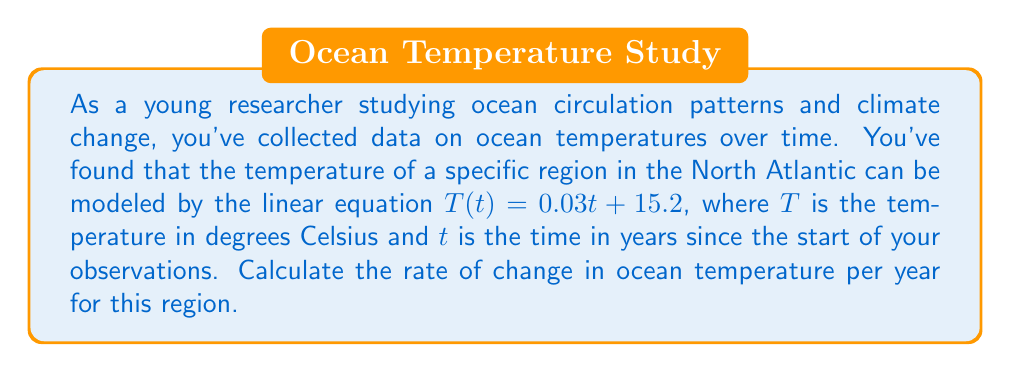Could you help me with this problem? To find the rate of change in ocean temperature over time, we need to analyze the given linear equation:

$T(t) = 0.03t + 15.2$

This equation is in the slope-intercept form of a linear equation: $y = mx + b$, where:
- $y$ represents the dependent variable (temperature $T$ in this case)
- $x$ represents the independent variable (time $t$ in this case)
- $m$ represents the slope of the line
- $b$ represents the y-intercept

In our equation:
- $m = 0.03$
- $b = 15.2$

The slope $m$ represents the rate of change of $y$ with respect to $x$. In this context, it represents the rate of change of temperature with respect to time.

Therefore, the rate of change in ocean temperature is 0.03 degrees Celsius per year.

This means that for each year that passes, the ocean temperature in this region increases by 0.03°C.
Answer: 0.03°C/year 